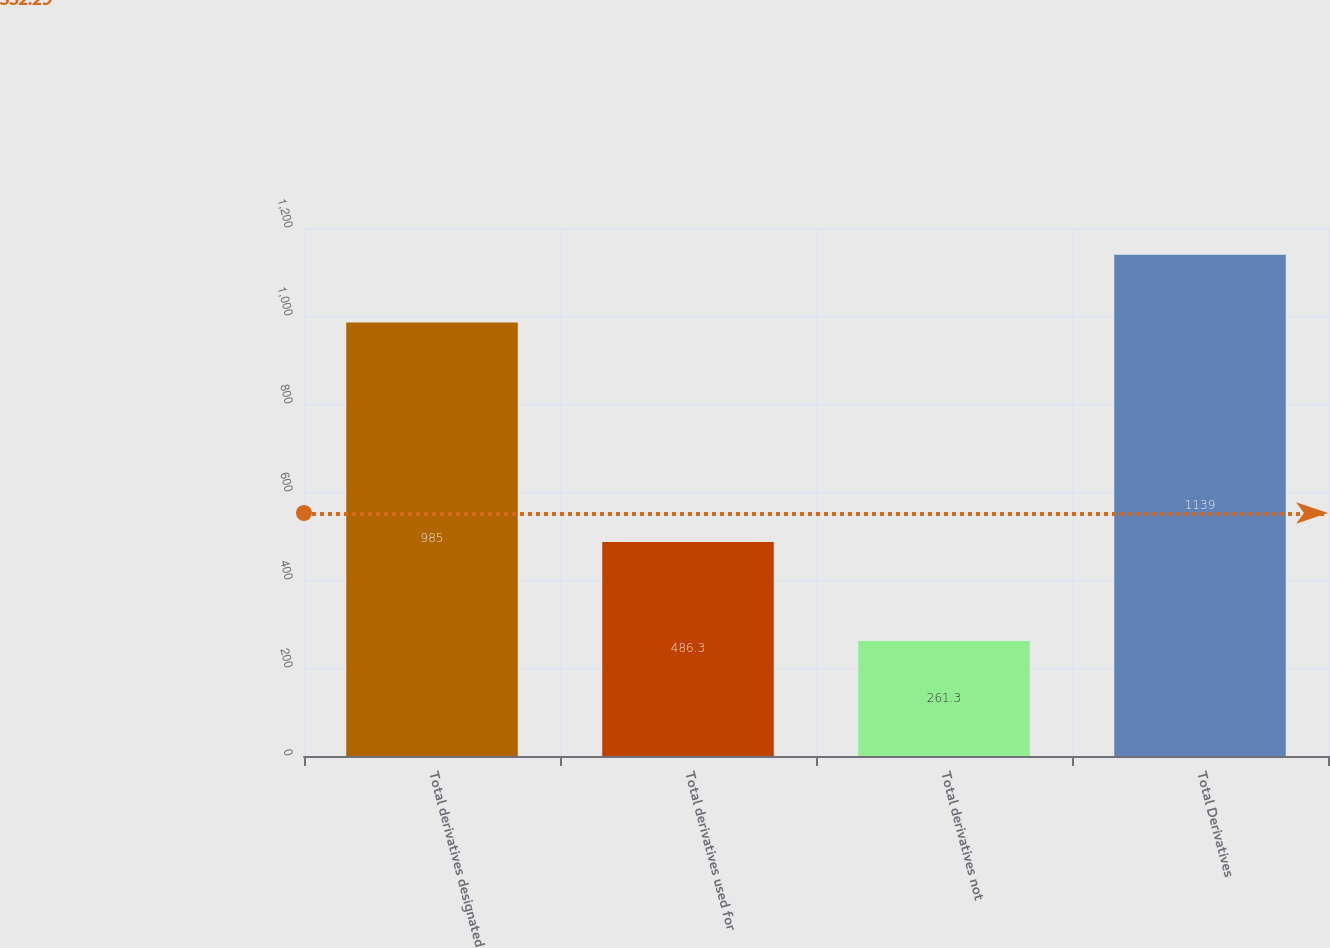Convert chart to OTSL. <chart><loc_0><loc_0><loc_500><loc_500><bar_chart><fcel>Total derivatives designated<fcel>Total derivatives used for<fcel>Total derivatives not<fcel>Total Derivatives<nl><fcel>985<fcel>486.3<fcel>261.3<fcel>1139<nl></chart> 